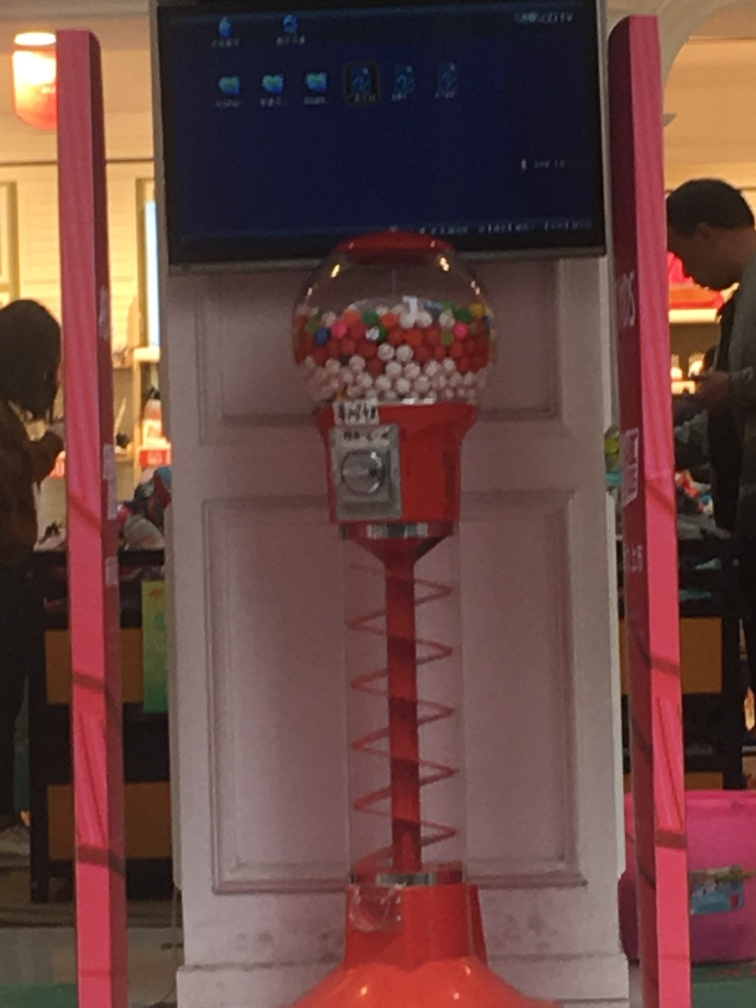What can you infer about the location where this gumball machine is placed? The gumball machine seems to be located in a bright, indoor environment, likely a mall or a store given the presence of what appears to be a sales counter in the background and other products on display. The vibrant pink elements suggest a playful or kid-friendly setting, possibly a candy store or a children's boutique. 